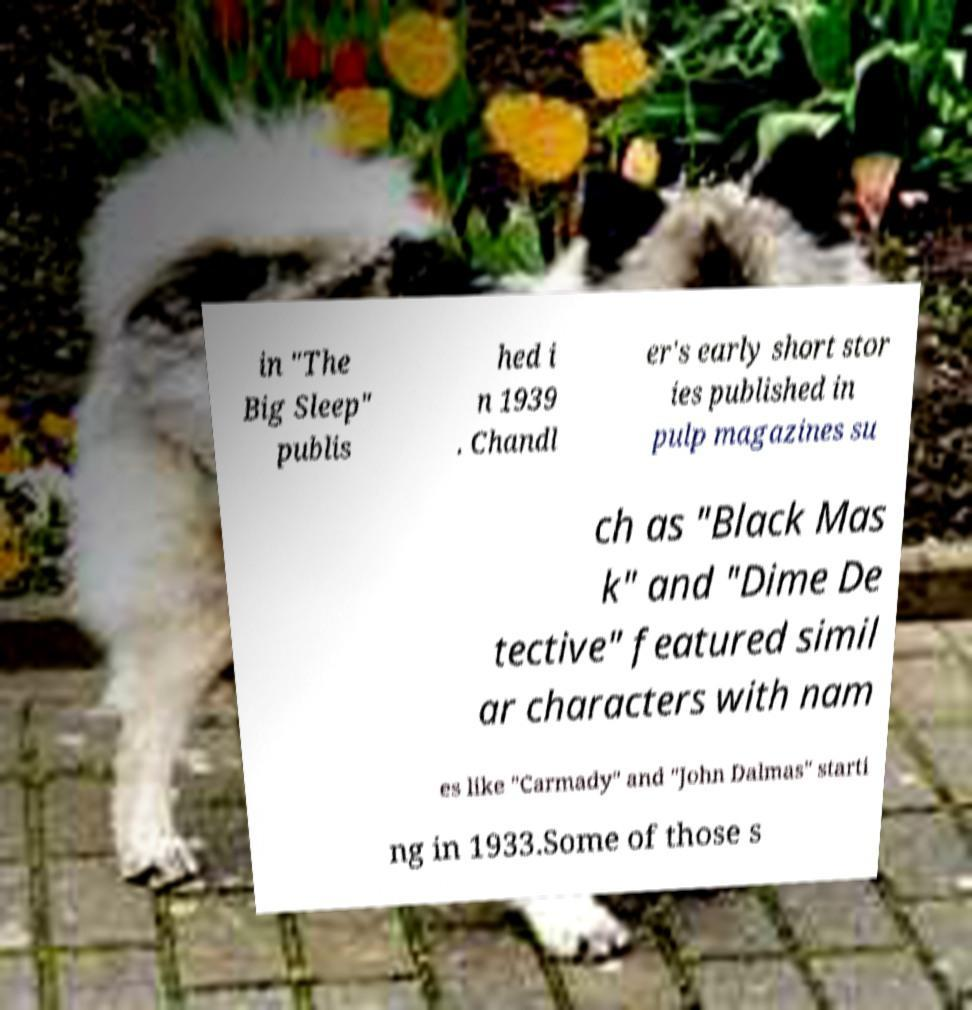I need the written content from this picture converted into text. Can you do that? in "The Big Sleep" publis hed i n 1939 . Chandl er's early short stor ies published in pulp magazines su ch as "Black Mas k" and "Dime De tective" featured simil ar characters with nam es like "Carmady" and "John Dalmas" starti ng in 1933.Some of those s 